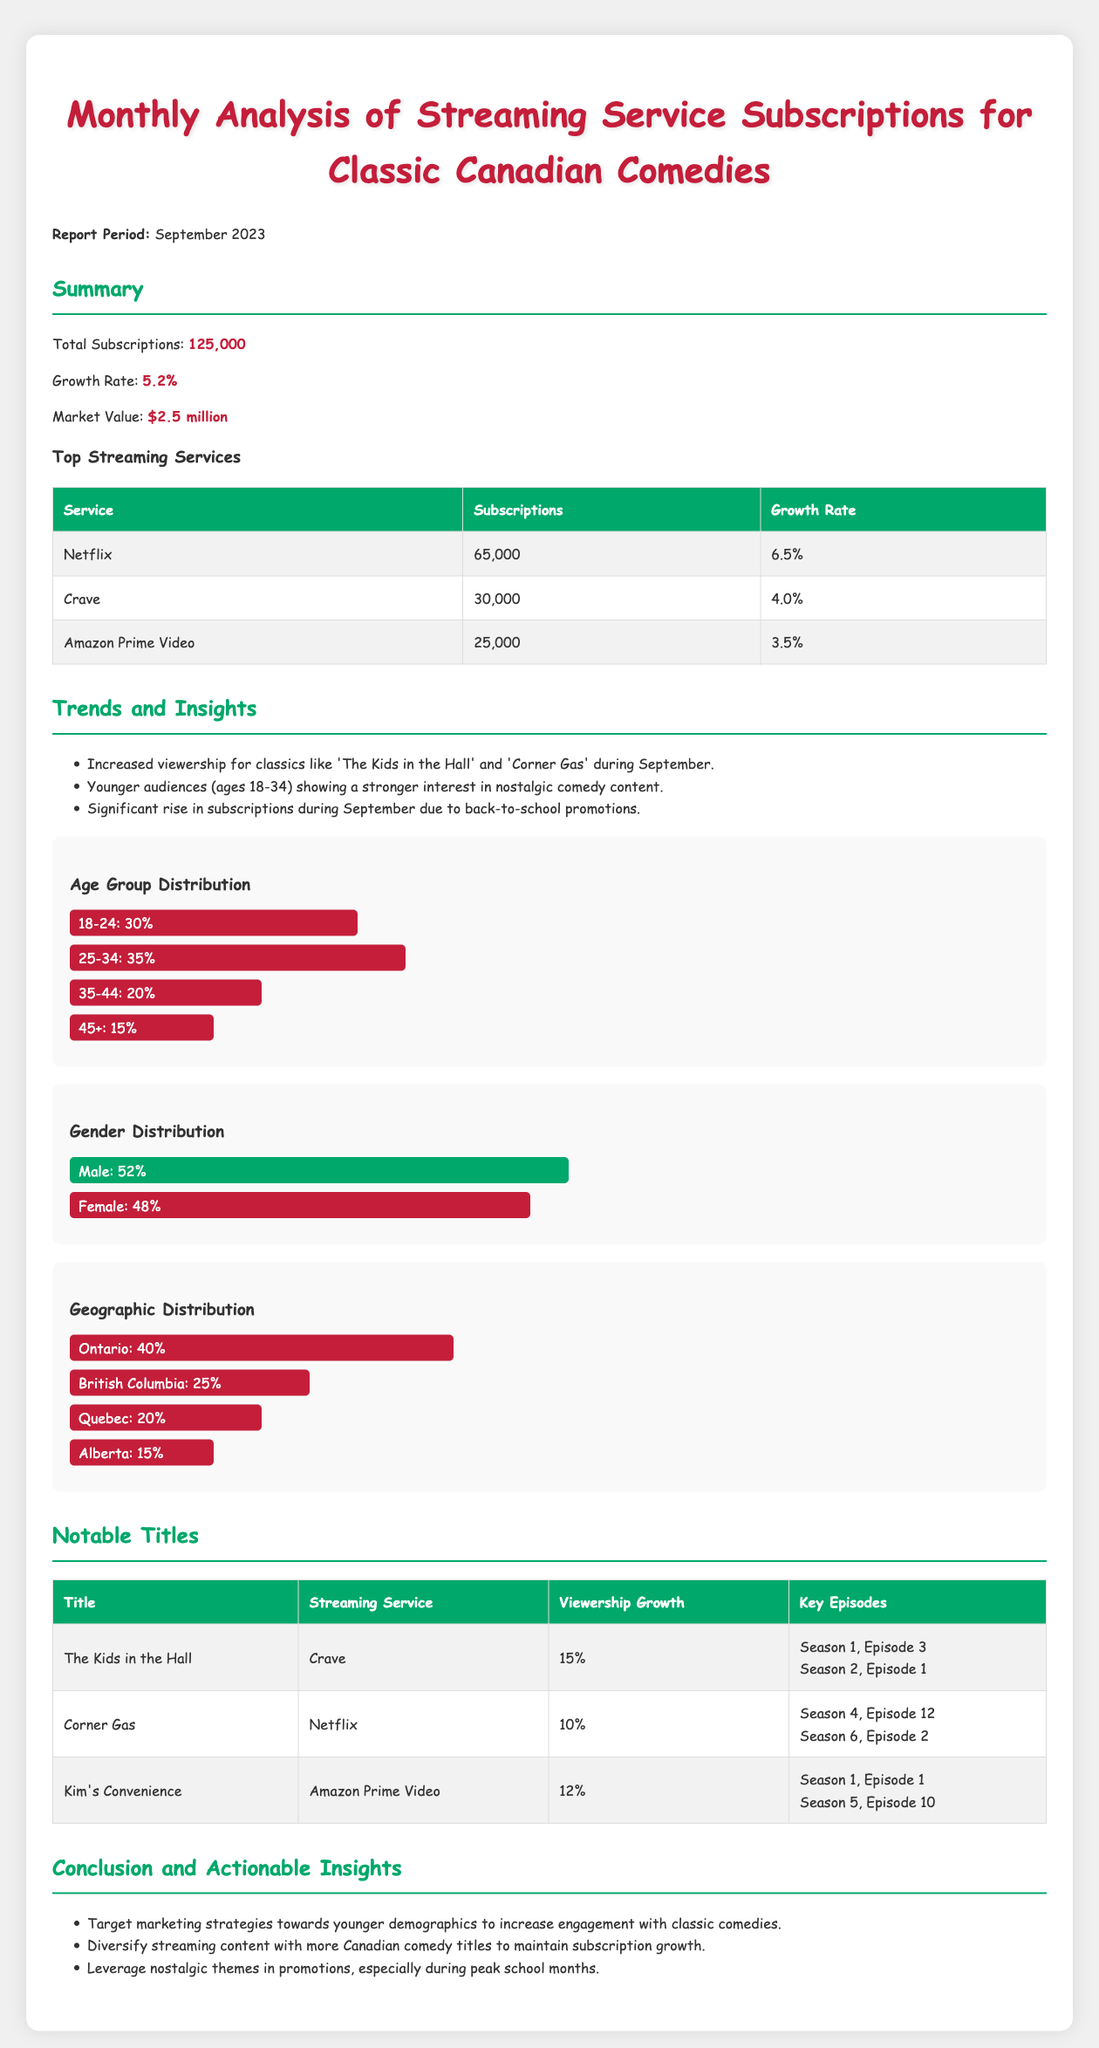What is the total number of subscriptions? The total number of subscriptions is stated directly in the summary section of the document.
Answer: 125,000 What is the growth rate of subscriptions? The growth rate is provided in the summary and indicates how much subscriptions have increased.
Answer: 5.2% Which streaming service has the highest number of subscriptions? The table in the summary lists the streaming services and their respective subscriptions, identifying the highest.
Answer: Netflix What age group has the highest percentage of subscriptions? The age distribution chart shows the percentage of subscriptions by age group, allowing easy identification of the highest.
Answer: 25-34 What was the viewership growth for "The Kids in the Hall"? The notable titles section specifies the viewership growth for each notable title listed.
Answer: 15% Which province has the highest geographic distribution? The geographic distribution chart provides bar segments for different provinces, showing which has the largest share.
Answer: Ontario What marketing strategy is suggested to increase engagement with classic comedies? The conclusion indicates actionable insights, including strategies to target demographics for better engagement.
Answer: Target marketing towards younger demographics Which service streams "Corner Gas"? The notable titles section specifies the streaming service for each of the listed titles, identifying where "Corner Gas" can be found.
Answer: Netflix What was the notable episode for "Kim's Convenience"? The notable titles section lists key episodes for each show, focusing on "Kim's Convenience."
Answer: Season 1, Episode 1 